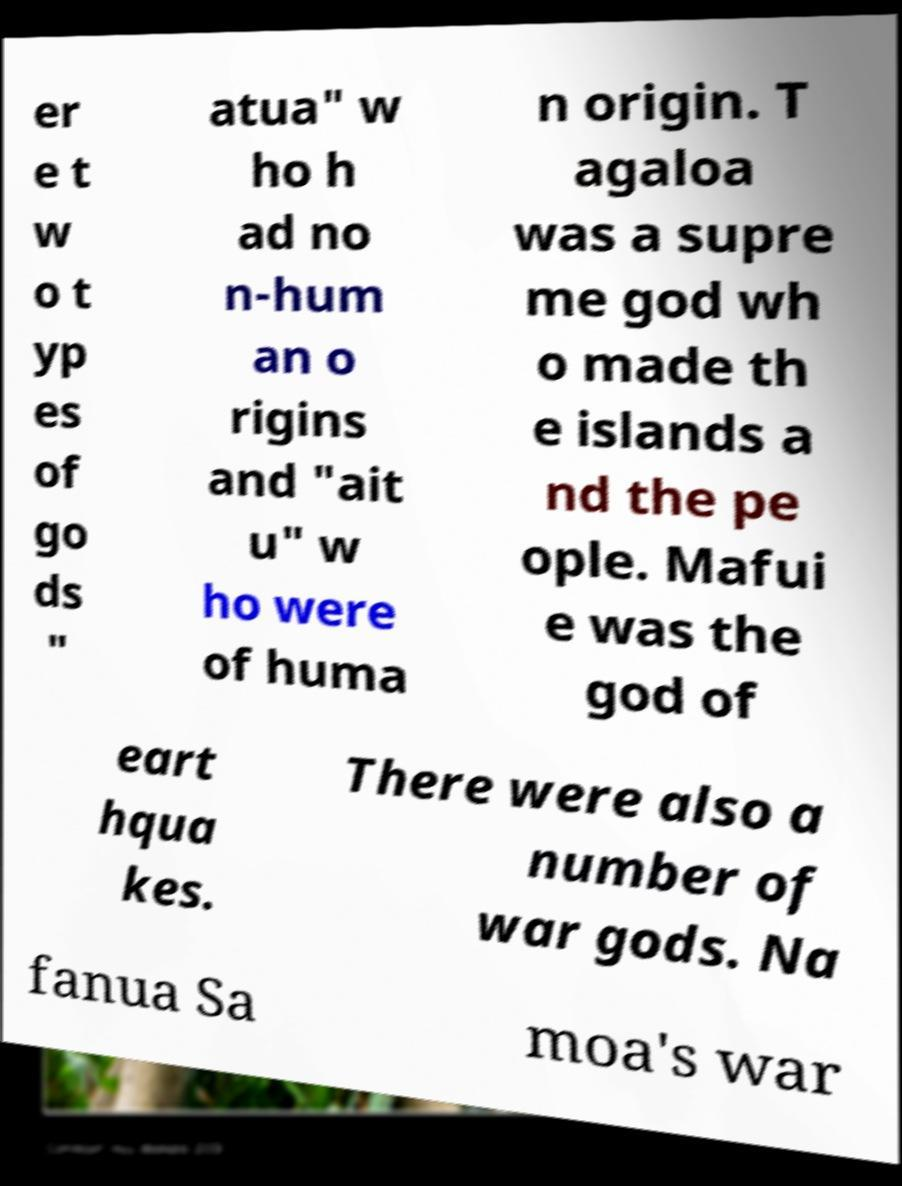Could you assist in decoding the text presented in this image and type it out clearly? er e t w o t yp es of go ds " atua" w ho h ad no n-hum an o rigins and "ait u" w ho were of huma n origin. T agaloa was a supre me god wh o made th e islands a nd the pe ople. Mafui e was the god of eart hqua kes. There were also a number of war gods. Na fanua Sa moa's war 